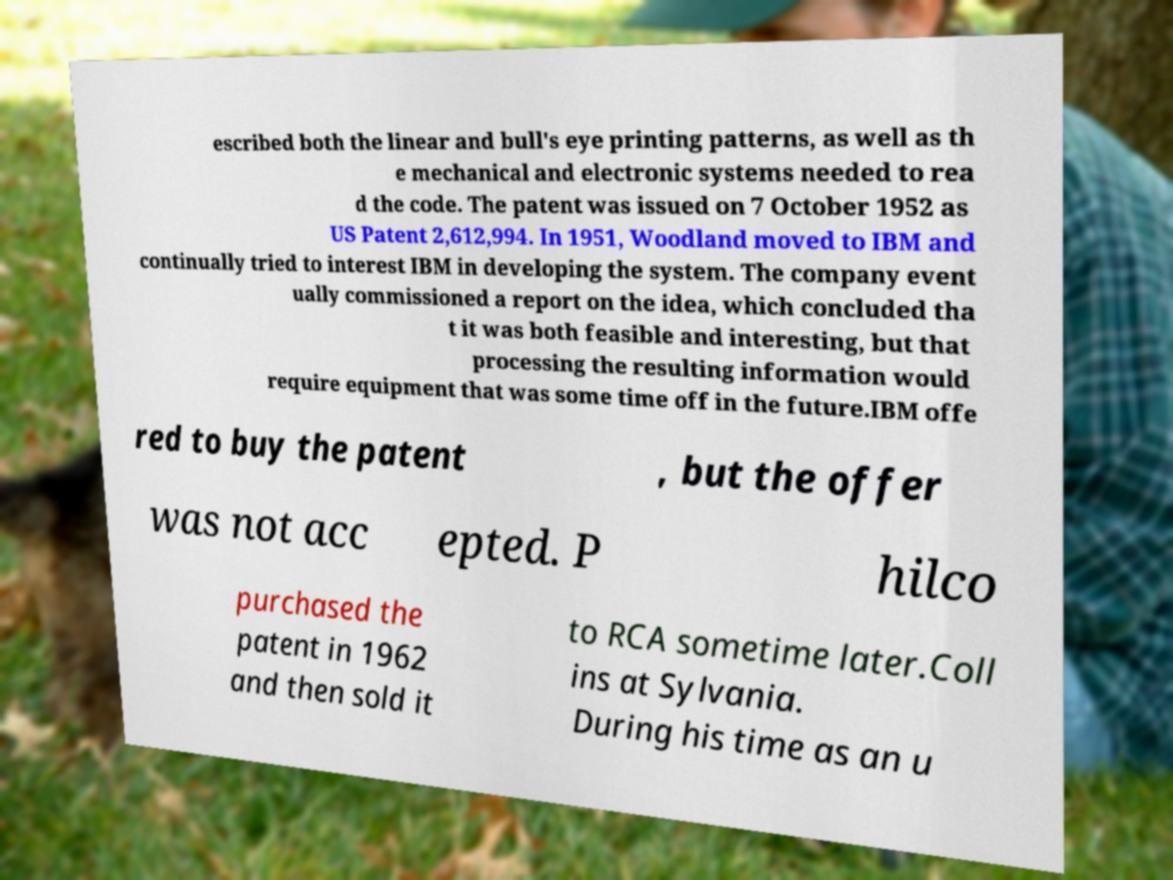Please read and relay the text visible in this image. What does it say? escribed both the linear and bull's eye printing patterns, as well as th e mechanical and electronic systems needed to rea d the code. The patent was issued on 7 October 1952 as US Patent 2,612,994. In 1951, Woodland moved to IBM and continually tried to interest IBM in developing the system. The company event ually commissioned a report on the idea, which concluded tha t it was both feasible and interesting, but that processing the resulting information would require equipment that was some time off in the future.IBM offe red to buy the patent , but the offer was not acc epted. P hilco purchased the patent in 1962 and then sold it to RCA sometime later.Coll ins at Sylvania. During his time as an u 